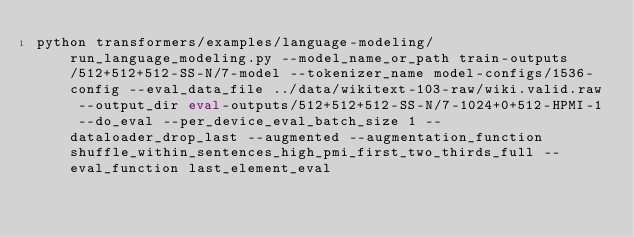<code> <loc_0><loc_0><loc_500><loc_500><_Bash_>python transformers/examples/language-modeling/run_language_modeling.py --model_name_or_path train-outputs/512+512+512-SS-N/7-model --tokenizer_name model-configs/1536-config --eval_data_file ../data/wikitext-103-raw/wiki.valid.raw --output_dir eval-outputs/512+512+512-SS-N/7-1024+0+512-HPMI-1 --do_eval --per_device_eval_batch_size 1 --dataloader_drop_last --augmented --augmentation_function shuffle_within_sentences_high_pmi_first_two_thirds_full --eval_function last_element_eval</code> 